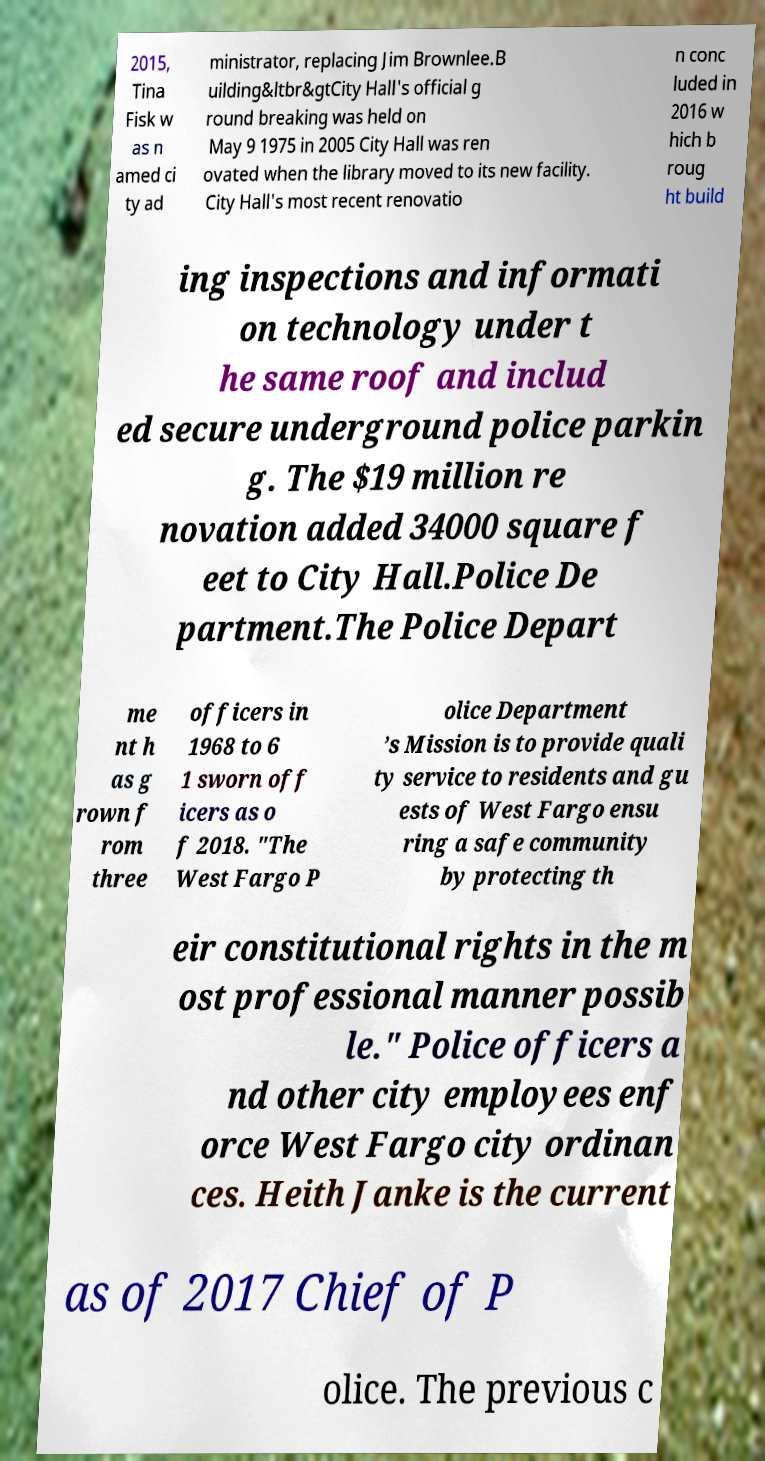There's text embedded in this image that I need extracted. Can you transcribe it verbatim? 2015, Tina Fisk w as n amed ci ty ad ministrator, replacing Jim Brownlee.B uilding&ltbr&gtCity Hall's official g round breaking was held on May 9 1975 in 2005 City Hall was ren ovated when the library moved to its new facility. City Hall's most recent renovatio n conc luded in 2016 w hich b roug ht build ing inspections and informati on technology under t he same roof and includ ed secure underground police parkin g. The $19 million re novation added 34000 square f eet to City Hall.Police De partment.The Police Depart me nt h as g rown f rom three officers in 1968 to 6 1 sworn off icers as o f 2018. "The West Fargo P olice Department ’s Mission is to provide quali ty service to residents and gu ests of West Fargo ensu ring a safe community by protecting th eir constitutional rights in the m ost professional manner possib le." Police officers a nd other city employees enf orce West Fargo city ordinan ces. Heith Janke is the current as of 2017 Chief of P olice. The previous c 